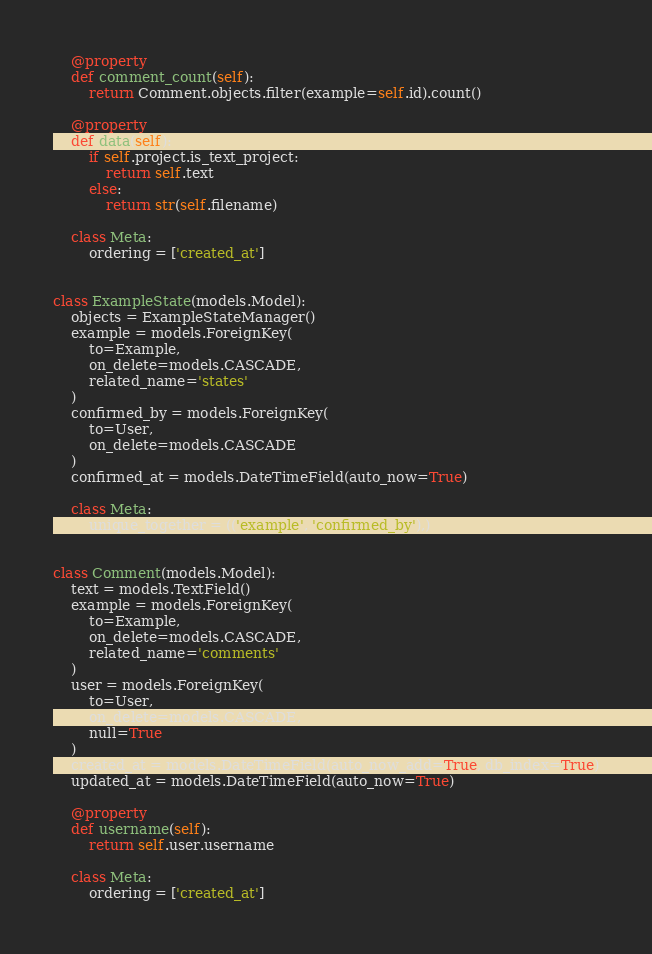<code> <loc_0><loc_0><loc_500><loc_500><_Python_>    @property
    def comment_count(self):
        return Comment.objects.filter(example=self.id).count()

    @property
    def data(self):
        if self.project.is_text_project:
            return self.text
        else:
            return str(self.filename)

    class Meta:
        ordering = ['created_at']


class ExampleState(models.Model):
    objects = ExampleStateManager()
    example = models.ForeignKey(
        to=Example,
        on_delete=models.CASCADE,
        related_name='states'
    )
    confirmed_by = models.ForeignKey(
        to=User,
        on_delete=models.CASCADE
    )
    confirmed_at = models.DateTimeField(auto_now=True)

    class Meta:
        unique_together = (('example', 'confirmed_by'),)


class Comment(models.Model):
    text = models.TextField()
    example = models.ForeignKey(
        to=Example,
        on_delete=models.CASCADE,
        related_name='comments'
    )
    user = models.ForeignKey(
        to=User,
        on_delete=models.CASCADE,
        null=True
    )
    created_at = models.DateTimeField(auto_now_add=True, db_index=True)
    updated_at = models.DateTimeField(auto_now=True)

    @property
    def username(self):
        return self.user.username

    class Meta:
        ordering = ['created_at']
</code> 